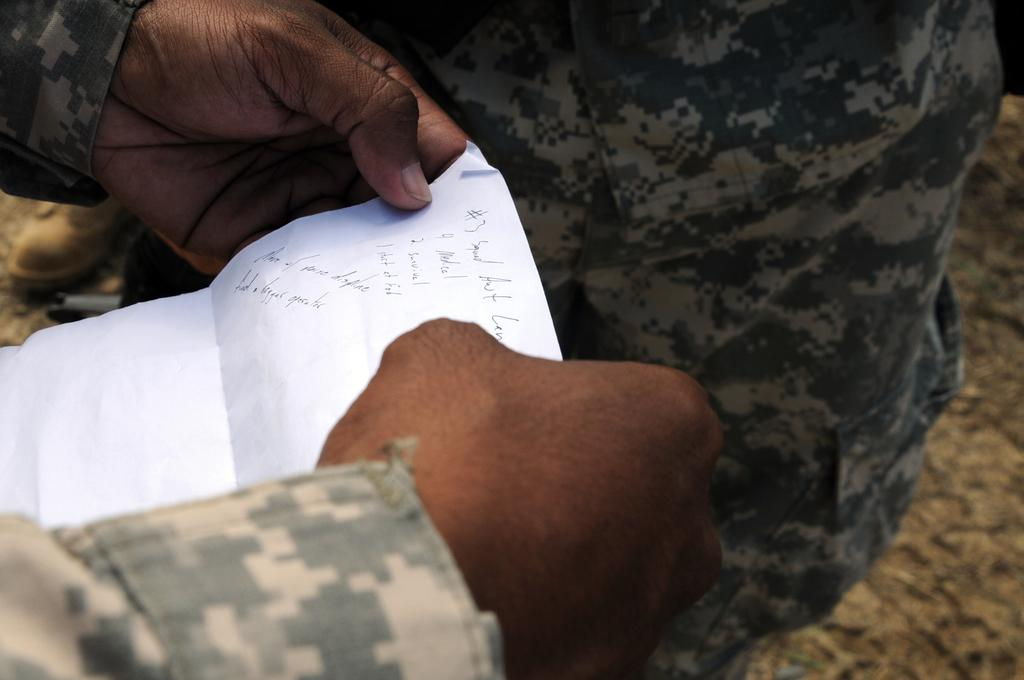What is the person holding in the image? The person is holding a paper in the image. Can you describe the other person in the image? There is another man wearing a shirt and trousers in the image. What part of the room can be seen on the right side of the image? The floor is visible on the right side of the image. What type of machine is being used by the person holding the paper in the image? There is no machine visible in the image; the person is simply holding a paper. How many shoes can be seen on the floor in the image? There is no shoe visible in the image; only the floor is visible on the right side. 